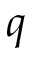Convert formula to latex. <formula><loc_0><loc_0><loc_500><loc_500>q</formula> 